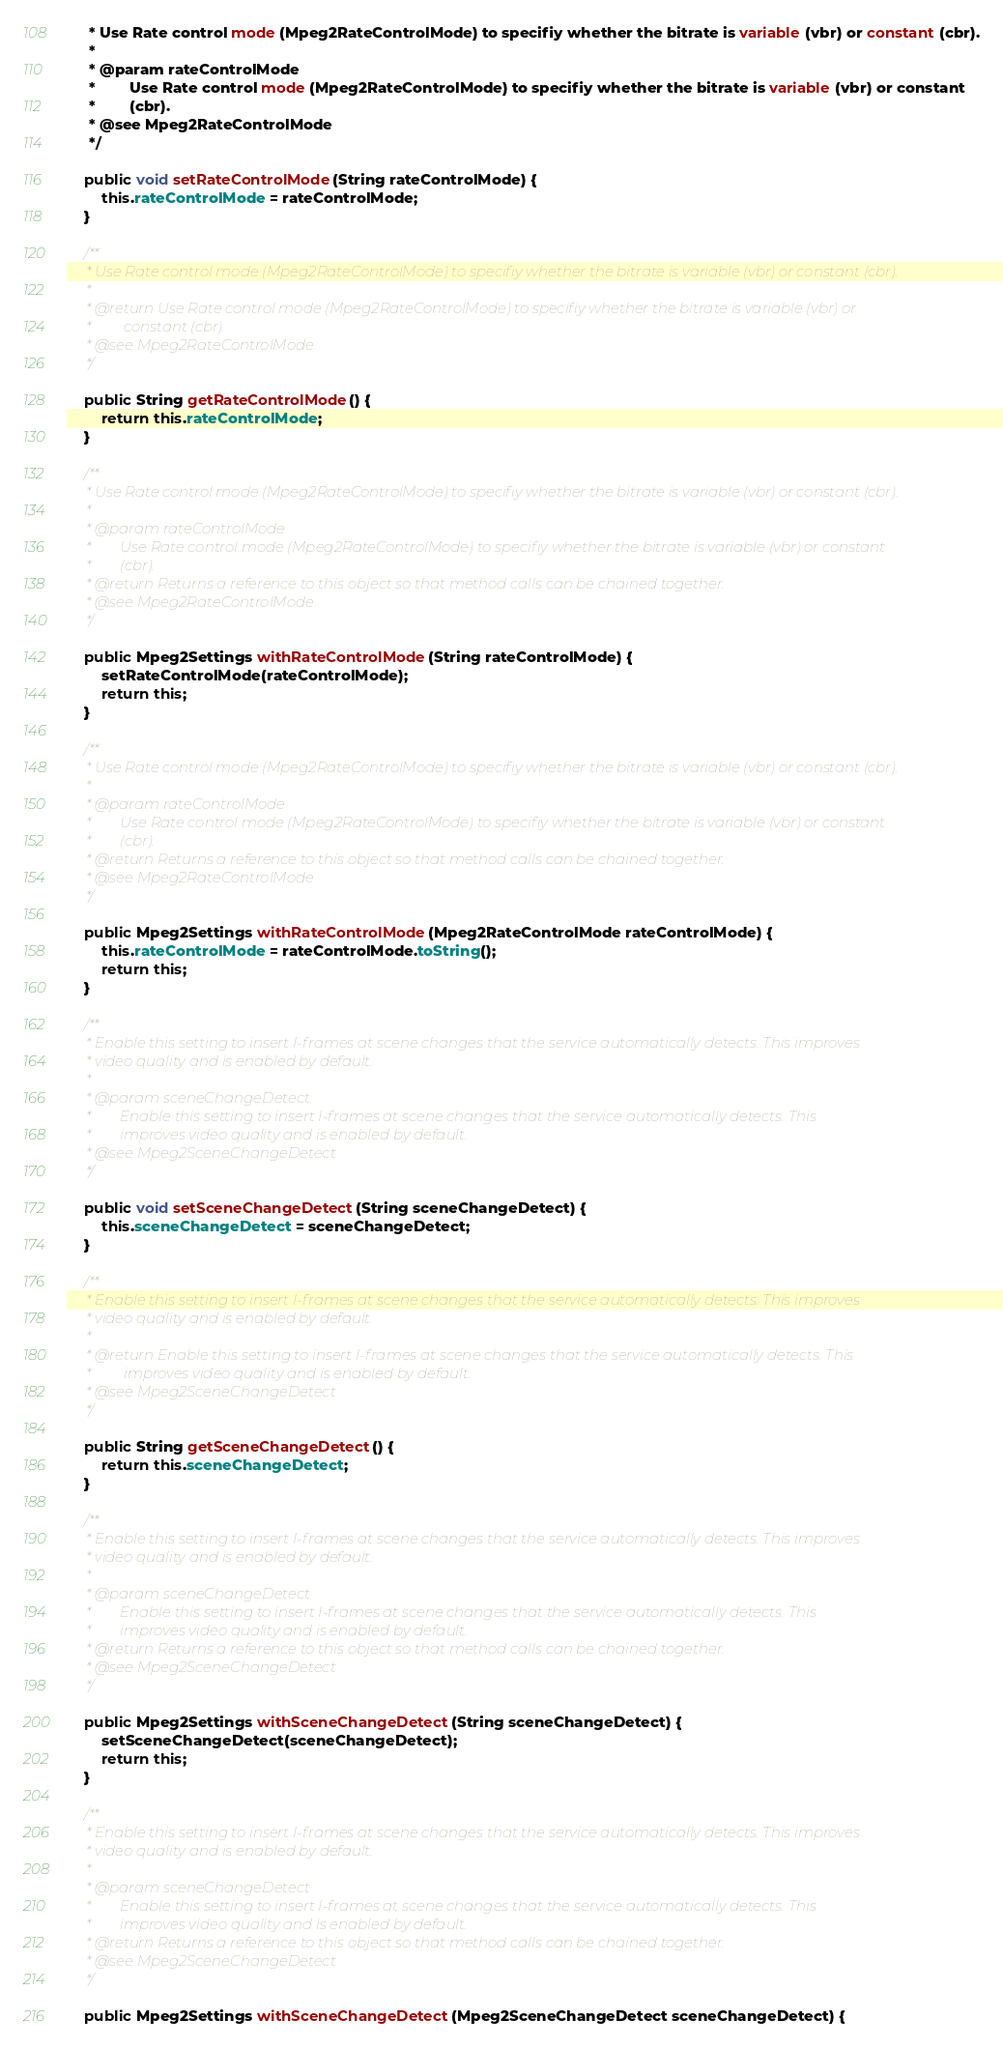<code> <loc_0><loc_0><loc_500><loc_500><_Java_>     * Use Rate control mode (Mpeg2RateControlMode) to specifiy whether the bitrate is variable (vbr) or constant (cbr).
     * 
     * @param rateControlMode
     *        Use Rate control mode (Mpeg2RateControlMode) to specifiy whether the bitrate is variable (vbr) or constant
     *        (cbr).
     * @see Mpeg2RateControlMode
     */

    public void setRateControlMode(String rateControlMode) {
        this.rateControlMode = rateControlMode;
    }

    /**
     * Use Rate control mode (Mpeg2RateControlMode) to specifiy whether the bitrate is variable (vbr) or constant (cbr).
     * 
     * @return Use Rate control mode (Mpeg2RateControlMode) to specifiy whether the bitrate is variable (vbr) or
     *         constant (cbr).
     * @see Mpeg2RateControlMode
     */

    public String getRateControlMode() {
        return this.rateControlMode;
    }

    /**
     * Use Rate control mode (Mpeg2RateControlMode) to specifiy whether the bitrate is variable (vbr) or constant (cbr).
     * 
     * @param rateControlMode
     *        Use Rate control mode (Mpeg2RateControlMode) to specifiy whether the bitrate is variable (vbr) or constant
     *        (cbr).
     * @return Returns a reference to this object so that method calls can be chained together.
     * @see Mpeg2RateControlMode
     */

    public Mpeg2Settings withRateControlMode(String rateControlMode) {
        setRateControlMode(rateControlMode);
        return this;
    }

    /**
     * Use Rate control mode (Mpeg2RateControlMode) to specifiy whether the bitrate is variable (vbr) or constant (cbr).
     * 
     * @param rateControlMode
     *        Use Rate control mode (Mpeg2RateControlMode) to specifiy whether the bitrate is variable (vbr) or constant
     *        (cbr).
     * @return Returns a reference to this object so that method calls can be chained together.
     * @see Mpeg2RateControlMode
     */

    public Mpeg2Settings withRateControlMode(Mpeg2RateControlMode rateControlMode) {
        this.rateControlMode = rateControlMode.toString();
        return this;
    }

    /**
     * Enable this setting to insert I-frames at scene changes that the service automatically detects. This improves
     * video quality and is enabled by default.
     * 
     * @param sceneChangeDetect
     *        Enable this setting to insert I-frames at scene changes that the service automatically detects. This
     *        improves video quality and is enabled by default.
     * @see Mpeg2SceneChangeDetect
     */

    public void setSceneChangeDetect(String sceneChangeDetect) {
        this.sceneChangeDetect = sceneChangeDetect;
    }

    /**
     * Enable this setting to insert I-frames at scene changes that the service automatically detects. This improves
     * video quality and is enabled by default.
     * 
     * @return Enable this setting to insert I-frames at scene changes that the service automatically detects. This
     *         improves video quality and is enabled by default.
     * @see Mpeg2SceneChangeDetect
     */

    public String getSceneChangeDetect() {
        return this.sceneChangeDetect;
    }

    /**
     * Enable this setting to insert I-frames at scene changes that the service automatically detects. This improves
     * video quality and is enabled by default.
     * 
     * @param sceneChangeDetect
     *        Enable this setting to insert I-frames at scene changes that the service automatically detects. This
     *        improves video quality and is enabled by default.
     * @return Returns a reference to this object so that method calls can be chained together.
     * @see Mpeg2SceneChangeDetect
     */

    public Mpeg2Settings withSceneChangeDetect(String sceneChangeDetect) {
        setSceneChangeDetect(sceneChangeDetect);
        return this;
    }

    /**
     * Enable this setting to insert I-frames at scene changes that the service automatically detects. This improves
     * video quality and is enabled by default.
     * 
     * @param sceneChangeDetect
     *        Enable this setting to insert I-frames at scene changes that the service automatically detects. This
     *        improves video quality and is enabled by default.
     * @return Returns a reference to this object so that method calls can be chained together.
     * @see Mpeg2SceneChangeDetect
     */

    public Mpeg2Settings withSceneChangeDetect(Mpeg2SceneChangeDetect sceneChangeDetect) {</code> 